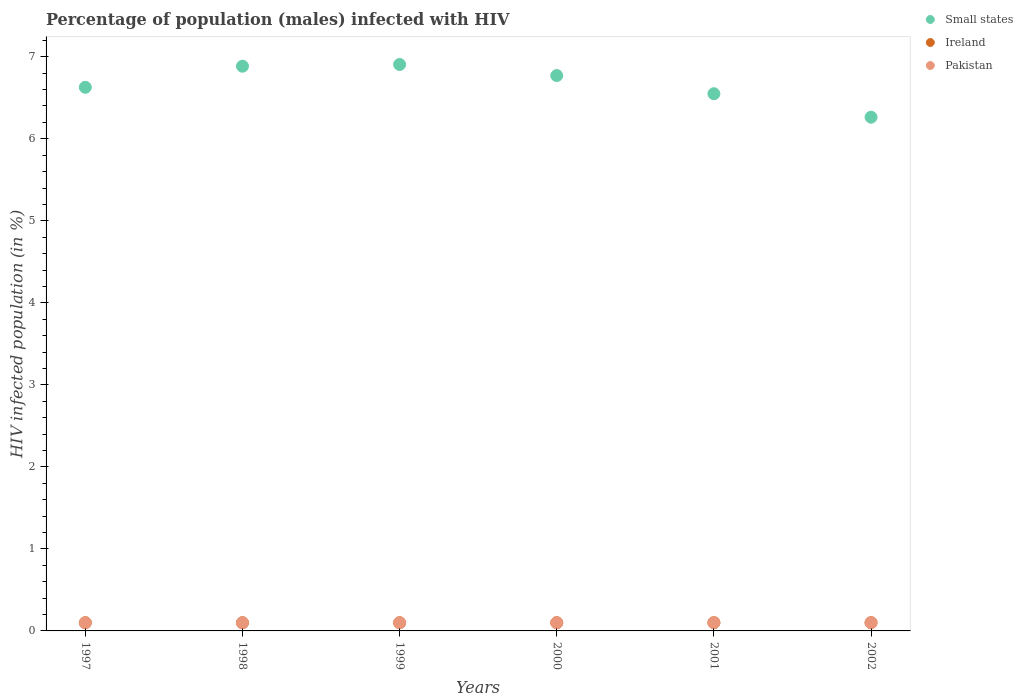How many different coloured dotlines are there?
Offer a very short reply. 3. Is the number of dotlines equal to the number of legend labels?
Provide a succinct answer. Yes. Across all years, what is the maximum percentage of HIV infected male population in Small states?
Offer a very short reply. 6.91. Across all years, what is the minimum percentage of HIV infected male population in Small states?
Give a very brief answer. 6.26. In which year was the percentage of HIV infected male population in Ireland maximum?
Ensure brevity in your answer.  1997. What is the total percentage of HIV infected male population in Ireland in the graph?
Your answer should be compact. 0.6. What is the difference between the percentage of HIV infected male population in Pakistan in 2000 and that in 2001?
Give a very brief answer. 0. What is the difference between the percentage of HIV infected male population in Ireland in 1998 and the percentage of HIV infected male population in Small states in 2002?
Your response must be concise. -6.16. What is the average percentage of HIV infected male population in Ireland per year?
Offer a terse response. 0.1. In the year 1997, what is the difference between the percentage of HIV infected male population in Small states and percentage of HIV infected male population in Ireland?
Provide a short and direct response. 6.53. In how many years, is the percentage of HIV infected male population in Pakistan greater than 7 %?
Your answer should be very brief. 0. What is the ratio of the percentage of HIV infected male population in Ireland in 1998 to that in 2001?
Provide a short and direct response. 1. Is the percentage of HIV infected male population in Small states in 1998 less than that in 1999?
Ensure brevity in your answer.  Yes. What is the difference between the highest and the lowest percentage of HIV infected male population in Ireland?
Ensure brevity in your answer.  0. In how many years, is the percentage of HIV infected male population in Small states greater than the average percentage of HIV infected male population in Small states taken over all years?
Ensure brevity in your answer.  3. Is the sum of the percentage of HIV infected male population in Small states in 1998 and 2002 greater than the maximum percentage of HIV infected male population in Pakistan across all years?
Make the answer very short. Yes. Is the percentage of HIV infected male population in Ireland strictly greater than the percentage of HIV infected male population in Pakistan over the years?
Make the answer very short. No. Is the percentage of HIV infected male population in Ireland strictly less than the percentage of HIV infected male population in Pakistan over the years?
Your answer should be very brief. No. Are the values on the major ticks of Y-axis written in scientific E-notation?
Your answer should be very brief. No. Does the graph contain any zero values?
Your answer should be compact. No. How are the legend labels stacked?
Ensure brevity in your answer.  Vertical. What is the title of the graph?
Provide a short and direct response. Percentage of population (males) infected with HIV. What is the label or title of the Y-axis?
Your answer should be compact. HIV infected population (in %). What is the HIV infected population (in %) in Small states in 1997?
Offer a very short reply. 6.63. What is the HIV infected population (in %) in Small states in 1998?
Your answer should be very brief. 6.89. What is the HIV infected population (in %) in Pakistan in 1998?
Make the answer very short. 0.1. What is the HIV infected population (in %) of Small states in 1999?
Provide a short and direct response. 6.91. What is the HIV infected population (in %) of Pakistan in 1999?
Offer a very short reply. 0.1. What is the HIV infected population (in %) of Small states in 2000?
Offer a very short reply. 6.77. What is the HIV infected population (in %) in Ireland in 2000?
Offer a very short reply. 0.1. What is the HIV infected population (in %) in Pakistan in 2000?
Ensure brevity in your answer.  0.1. What is the HIV infected population (in %) of Small states in 2001?
Your response must be concise. 6.55. What is the HIV infected population (in %) in Small states in 2002?
Provide a short and direct response. 6.26. What is the HIV infected population (in %) in Ireland in 2002?
Offer a very short reply. 0.1. Across all years, what is the maximum HIV infected population (in %) in Small states?
Ensure brevity in your answer.  6.91. Across all years, what is the maximum HIV infected population (in %) of Pakistan?
Keep it short and to the point. 0.1. Across all years, what is the minimum HIV infected population (in %) of Small states?
Provide a succinct answer. 6.26. Across all years, what is the minimum HIV infected population (in %) in Ireland?
Your response must be concise. 0.1. Across all years, what is the minimum HIV infected population (in %) of Pakistan?
Ensure brevity in your answer.  0.1. What is the total HIV infected population (in %) of Small states in the graph?
Your answer should be very brief. 40. What is the total HIV infected population (in %) in Ireland in the graph?
Provide a succinct answer. 0.6. What is the total HIV infected population (in %) in Pakistan in the graph?
Keep it short and to the point. 0.6. What is the difference between the HIV infected population (in %) in Small states in 1997 and that in 1998?
Keep it short and to the point. -0.26. What is the difference between the HIV infected population (in %) of Pakistan in 1997 and that in 1998?
Ensure brevity in your answer.  0. What is the difference between the HIV infected population (in %) of Small states in 1997 and that in 1999?
Provide a short and direct response. -0.28. What is the difference between the HIV infected population (in %) in Ireland in 1997 and that in 1999?
Keep it short and to the point. 0. What is the difference between the HIV infected population (in %) in Small states in 1997 and that in 2000?
Give a very brief answer. -0.14. What is the difference between the HIV infected population (in %) of Small states in 1997 and that in 2001?
Provide a short and direct response. 0.08. What is the difference between the HIV infected population (in %) in Small states in 1997 and that in 2002?
Provide a succinct answer. 0.36. What is the difference between the HIV infected population (in %) of Pakistan in 1997 and that in 2002?
Your response must be concise. 0. What is the difference between the HIV infected population (in %) in Small states in 1998 and that in 1999?
Provide a succinct answer. -0.02. What is the difference between the HIV infected population (in %) in Pakistan in 1998 and that in 1999?
Offer a terse response. 0. What is the difference between the HIV infected population (in %) of Small states in 1998 and that in 2000?
Offer a terse response. 0.11. What is the difference between the HIV infected population (in %) of Small states in 1998 and that in 2001?
Ensure brevity in your answer.  0.34. What is the difference between the HIV infected population (in %) of Ireland in 1998 and that in 2001?
Offer a terse response. 0. What is the difference between the HIV infected population (in %) in Pakistan in 1998 and that in 2001?
Make the answer very short. 0. What is the difference between the HIV infected population (in %) of Small states in 1998 and that in 2002?
Keep it short and to the point. 0.62. What is the difference between the HIV infected population (in %) in Ireland in 1998 and that in 2002?
Your answer should be compact. 0. What is the difference between the HIV infected population (in %) in Pakistan in 1998 and that in 2002?
Your response must be concise. 0. What is the difference between the HIV infected population (in %) of Small states in 1999 and that in 2000?
Provide a succinct answer. 0.13. What is the difference between the HIV infected population (in %) of Ireland in 1999 and that in 2000?
Your response must be concise. 0. What is the difference between the HIV infected population (in %) in Small states in 1999 and that in 2001?
Ensure brevity in your answer.  0.36. What is the difference between the HIV infected population (in %) of Small states in 1999 and that in 2002?
Make the answer very short. 0.64. What is the difference between the HIV infected population (in %) in Ireland in 1999 and that in 2002?
Your answer should be compact. 0. What is the difference between the HIV infected population (in %) in Small states in 2000 and that in 2001?
Provide a succinct answer. 0.22. What is the difference between the HIV infected population (in %) of Ireland in 2000 and that in 2001?
Your response must be concise. 0. What is the difference between the HIV infected population (in %) of Pakistan in 2000 and that in 2001?
Provide a succinct answer. 0. What is the difference between the HIV infected population (in %) of Small states in 2000 and that in 2002?
Your response must be concise. 0.51. What is the difference between the HIV infected population (in %) of Ireland in 2000 and that in 2002?
Keep it short and to the point. 0. What is the difference between the HIV infected population (in %) in Small states in 2001 and that in 2002?
Your answer should be very brief. 0.29. What is the difference between the HIV infected population (in %) of Ireland in 2001 and that in 2002?
Make the answer very short. 0. What is the difference between the HIV infected population (in %) in Small states in 1997 and the HIV infected population (in %) in Ireland in 1998?
Keep it short and to the point. 6.53. What is the difference between the HIV infected population (in %) of Small states in 1997 and the HIV infected population (in %) of Pakistan in 1998?
Offer a terse response. 6.53. What is the difference between the HIV infected population (in %) of Small states in 1997 and the HIV infected population (in %) of Ireland in 1999?
Your answer should be very brief. 6.53. What is the difference between the HIV infected population (in %) in Small states in 1997 and the HIV infected population (in %) in Pakistan in 1999?
Your answer should be compact. 6.53. What is the difference between the HIV infected population (in %) of Small states in 1997 and the HIV infected population (in %) of Ireland in 2000?
Provide a short and direct response. 6.53. What is the difference between the HIV infected population (in %) in Small states in 1997 and the HIV infected population (in %) in Pakistan in 2000?
Your answer should be compact. 6.53. What is the difference between the HIV infected population (in %) in Ireland in 1997 and the HIV infected population (in %) in Pakistan in 2000?
Offer a very short reply. 0. What is the difference between the HIV infected population (in %) of Small states in 1997 and the HIV infected population (in %) of Ireland in 2001?
Provide a succinct answer. 6.53. What is the difference between the HIV infected population (in %) in Small states in 1997 and the HIV infected population (in %) in Pakistan in 2001?
Offer a terse response. 6.53. What is the difference between the HIV infected population (in %) of Small states in 1997 and the HIV infected population (in %) of Ireland in 2002?
Make the answer very short. 6.53. What is the difference between the HIV infected population (in %) in Small states in 1997 and the HIV infected population (in %) in Pakistan in 2002?
Your response must be concise. 6.53. What is the difference between the HIV infected population (in %) of Small states in 1998 and the HIV infected population (in %) of Ireland in 1999?
Make the answer very short. 6.79. What is the difference between the HIV infected population (in %) in Small states in 1998 and the HIV infected population (in %) in Pakistan in 1999?
Offer a very short reply. 6.79. What is the difference between the HIV infected population (in %) in Small states in 1998 and the HIV infected population (in %) in Ireland in 2000?
Provide a short and direct response. 6.79. What is the difference between the HIV infected population (in %) in Small states in 1998 and the HIV infected population (in %) in Pakistan in 2000?
Your response must be concise. 6.79. What is the difference between the HIV infected population (in %) of Ireland in 1998 and the HIV infected population (in %) of Pakistan in 2000?
Provide a short and direct response. 0. What is the difference between the HIV infected population (in %) in Small states in 1998 and the HIV infected population (in %) in Ireland in 2001?
Ensure brevity in your answer.  6.79. What is the difference between the HIV infected population (in %) in Small states in 1998 and the HIV infected population (in %) in Pakistan in 2001?
Keep it short and to the point. 6.79. What is the difference between the HIV infected population (in %) in Small states in 1998 and the HIV infected population (in %) in Ireland in 2002?
Keep it short and to the point. 6.79. What is the difference between the HIV infected population (in %) of Small states in 1998 and the HIV infected population (in %) of Pakistan in 2002?
Your response must be concise. 6.79. What is the difference between the HIV infected population (in %) of Ireland in 1998 and the HIV infected population (in %) of Pakistan in 2002?
Provide a succinct answer. 0. What is the difference between the HIV infected population (in %) in Small states in 1999 and the HIV infected population (in %) in Ireland in 2000?
Offer a terse response. 6.81. What is the difference between the HIV infected population (in %) of Small states in 1999 and the HIV infected population (in %) of Pakistan in 2000?
Provide a short and direct response. 6.81. What is the difference between the HIV infected population (in %) of Small states in 1999 and the HIV infected population (in %) of Ireland in 2001?
Provide a short and direct response. 6.81. What is the difference between the HIV infected population (in %) of Small states in 1999 and the HIV infected population (in %) of Pakistan in 2001?
Your answer should be very brief. 6.81. What is the difference between the HIV infected population (in %) in Ireland in 1999 and the HIV infected population (in %) in Pakistan in 2001?
Keep it short and to the point. 0. What is the difference between the HIV infected population (in %) in Small states in 1999 and the HIV infected population (in %) in Ireland in 2002?
Keep it short and to the point. 6.81. What is the difference between the HIV infected population (in %) of Small states in 1999 and the HIV infected population (in %) of Pakistan in 2002?
Make the answer very short. 6.81. What is the difference between the HIV infected population (in %) in Small states in 2000 and the HIV infected population (in %) in Ireland in 2001?
Your response must be concise. 6.67. What is the difference between the HIV infected population (in %) in Small states in 2000 and the HIV infected population (in %) in Pakistan in 2001?
Your response must be concise. 6.67. What is the difference between the HIV infected population (in %) of Small states in 2000 and the HIV infected population (in %) of Ireland in 2002?
Give a very brief answer. 6.67. What is the difference between the HIV infected population (in %) in Small states in 2000 and the HIV infected population (in %) in Pakistan in 2002?
Provide a succinct answer. 6.67. What is the difference between the HIV infected population (in %) in Small states in 2001 and the HIV infected population (in %) in Ireland in 2002?
Your response must be concise. 6.45. What is the difference between the HIV infected population (in %) in Small states in 2001 and the HIV infected population (in %) in Pakistan in 2002?
Offer a very short reply. 6.45. What is the average HIV infected population (in %) in Small states per year?
Make the answer very short. 6.67. What is the average HIV infected population (in %) in Ireland per year?
Keep it short and to the point. 0.1. In the year 1997, what is the difference between the HIV infected population (in %) of Small states and HIV infected population (in %) of Ireland?
Provide a short and direct response. 6.53. In the year 1997, what is the difference between the HIV infected population (in %) of Small states and HIV infected population (in %) of Pakistan?
Make the answer very short. 6.53. In the year 1997, what is the difference between the HIV infected population (in %) of Ireland and HIV infected population (in %) of Pakistan?
Your answer should be compact. 0. In the year 1998, what is the difference between the HIV infected population (in %) in Small states and HIV infected population (in %) in Ireland?
Offer a very short reply. 6.79. In the year 1998, what is the difference between the HIV infected population (in %) in Small states and HIV infected population (in %) in Pakistan?
Give a very brief answer. 6.79. In the year 1999, what is the difference between the HIV infected population (in %) in Small states and HIV infected population (in %) in Ireland?
Make the answer very short. 6.81. In the year 1999, what is the difference between the HIV infected population (in %) in Small states and HIV infected population (in %) in Pakistan?
Offer a terse response. 6.81. In the year 2000, what is the difference between the HIV infected population (in %) of Small states and HIV infected population (in %) of Ireland?
Your answer should be compact. 6.67. In the year 2000, what is the difference between the HIV infected population (in %) of Small states and HIV infected population (in %) of Pakistan?
Your answer should be very brief. 6.67. In the year 2001, what is the difference between the HIV infected population (in %) of Small states and HIV infected population (in %) of Ireland?
Your response must be concise. 6.45. In the year 2001, what is the difference between the HIV infected population (in %) in Small states and HIV infected population (in %) in Pakistan?
Make the answer very short. 6.45. In the year 2001, what is the difference between the HIV infected population (in %) of Ireland and HIV infected population (in %) of Pakistan?
Provide a short and direct response. 0. In the year 2002, what is the difference between the HIV infected population (in %) of Small states and HIV infected population (in %) of Ireland?
Your answer should be compact. 6.16. In the year 2002, what is the difference between the HIV infected population (in %) of Small states and HIV infected population (in %) of Pakistan?
Keep it short and to the point. 6.16. What is the ratio of the HIV infected population (in %) in Small states in 1997 to that in 1998?
Make the answer very short. 0.96. What is the ratio of the HIV infected population (in %) in Small states in 1997 to that in 1999?
Provide a short and direct response. 0.96. What is the ratio of the HIV infected population (in %) of Ireland in 1997 to that in 1999?
Offer a very short reply. 1. What is the ratio of the HIV infected population (in %) of Small states in 1997 to that in 2000?
Ensure brevity in your answer.  0.98. What is the ratio of the HIV infected population (in %) of Ireland in 1997 to that in 2000?
Your answer should be compact. 1. What is the ratio of the HIV infected population (in %) in Pakistan in 1997 to that in 2000?
Offer a very short reply. 1. What is the ratio of the HIV infected population (in %) in Ireland in 1997 to that in 2001?
Offer a very short reply. 1. What is the ratio of the HIV infected population (in %) in Small states in 1997 to that in 2002?
Give a very brief answer. 1.06. What is the ratio of the HIV infected population (in %) in Ireland in 1997 to that in 2002?
Your response must be concise. 1. What is the ratio of the HIV infected population (in %) in Small states in 1998 to that in 1999?
Your response must be concise. 1. What is the ratio of the HIV infected population (in %) of Pakistan in 1998 to that in 1999?
Offer a very short reply. 1. What is the ratio of the HIV infected population (in %) of Small states in 1998 to that in 2000?
Offer a very short reply. 1.02. What is the ratio of the HIV infected population (in %) of Ireland in 1998 to that in 2000?
Provide a succinct answer. 1. What is the ratio of the HIV infected population (in %) of Pakistan in 1998 to that in 2000?
Your answer should be very brief. 1. What is the ratio of the HIV infected population (in %) of Small states in 1998 to that in 2001?
Your answer should be compact. 1.05. What is the ratio of the HIV infected population (in %) in Small states in 1998 to that in 2002?
Offer a very short reply. 1.1. What is the ratio of the HIV infected population (in %) of Ireland in 1998 to that in 2002?
Give a very brief answer. 1. What is the ratio of the HIV infected population (in %) of Pakistan in 1998 to that in 2002?
Your response must be concise. 1. What is the ratio of the HIV infected population (in %) of Small states in 1999 to that in 2000?
Your response must be concise. 1.02. What is the ratio of the HIV infected population (in %) of Small states in 1999 to that in 2001?
Your answer should be very brief. 1.05. What is the ratio of the HIV infected population (in %) in Ireland in 1999 to that in 2001?
Ensure brevity in your answer.  1. What is the ratio of the HIV infected population (in %) of Small states in 1999 to that in 2002?
Your answer should be very brief. 1.1. What is the ratio of the HIV infected population (in %) in Small states in 2000 to that in 2001?
Ensure brevity in your answer.  1.03. What is the ratio of the HIV infected population (in %) of Ireland in 2000 to that in 2001?
Give a very brief answer. 1. What is the ratio of the HIV infected population (in %) in Pakistan in 2000 to that in 2001?
Offer a very short reply. 1. What is the ratio of the HIV infected population (in %) in Small states in 2000 to that in 2002?
Make the answer very short. 1.08. What is the ratio of the HIV infected population (in %) in Ireland in 2000 to that in 2002?
Offer a terse response. 1. What is the ratio of the HIV infected population (in %) of Small states in 2001 to that in 2002?
Make the answer very short. 1.05. What is the ratio of the HIV infected population (in %) in Pakistan in 2001 to that in 2002?
Offer a terse response. 1. What is the difference between the highest and the second highest HIV infected population (in %) of Small states?
Your answer should be compact. 0.02. What is the difference between the highest and the second highest HIV infected population (in %) in Ireland?
Offer a very short reply. 0. What is the difference between the highest and the lowest HIV infected population (in %) in Small states?
Give a very brief answer. 0.64. What is the difference between the highest and the lowest HIV infected population (in %) in Ireland?
Keep it short and to the point. 0. 